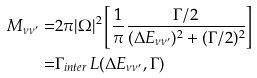<formula> <loc_0><loc_0><loc_500><loc_500>M _ { \nu \nu ^ { \prime } } = & 2 \pi | \Omega | ^ { 2 } \left [ \frac { 1 } { \pi } \frac { \Gamma / 2 } { ( \Delta E _ { \nu \nu ^ { \prime } } ) ^ { 2 } + ( \Gamma / 2 ) ^ { 2 } } \right ] \\ = & \Gamma _ { i n t e r } \, L ( \Delta E _ { \nu \nu ^ { \prime } } , \Gamma )</formula> 